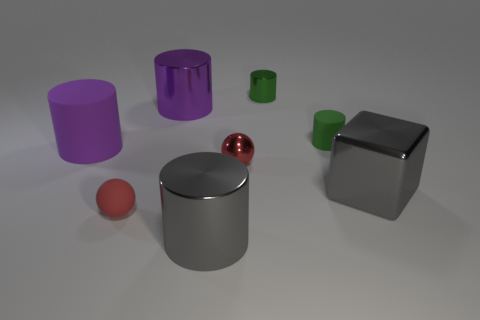Is there a cyan matte ball?
Offer a terse response. No. Is there anything else that is the same color as the small matte cylinder?
Offer a terse response. Yes. There is a green object that is made of the same material as the large gray block; what shape is it?
Provide a short and direct response. Cylinder. What color is the tiny cylinder behind the shiny thing that is to the left of the shiny object in front of the tiny red matte object?
Your response must be concise. Green. Are there an equal number of small metal balls to the right of the rubber sphere and big purple cylinders?
Provide a succinct answer. No. Is there anything else that has the same material as the large cube?
Ensure brevity in your answer.  Yes. Does the metal cube have the same color as the matte object that is in front of the block?
Provide a short and direct response. No. There is a gray thing on the left side of the gray object right of the tiny metallic cylinder; is there a gray cylinder that is in front of it?
Provide a succinct answer. No. Is the number of tiny green cylinders that are to the left of the large matte object less than the number of small brown rubber balls?
Keep it short and to the point. No. What number of other objects are the same shape as the red rubber object?
Provide a succinct answer. 1. 